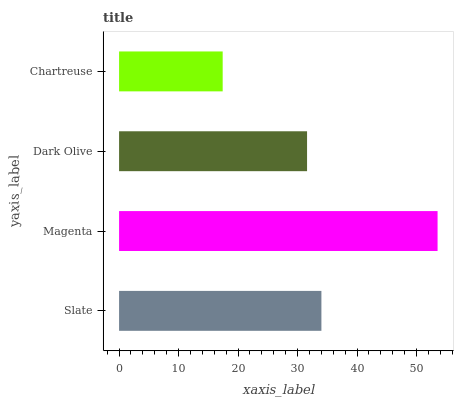Is Chartreuse the minimum?
Answer yes or no. Yes. Is Magenta the maximum?
Answer yes or no. Yes. Is Dark Olive the minimum?
Answer yes or no. No. Is Dark Olive the maximum?
Answer yes or no. No. Is Magenta greater than Dark Olive?
Answer yes or no. Yes. Is Dark Olive less than Magenta?
Answer yes or no. Yes. Is Dark Olive greater than Magenta?
Answer yes or no. No. Is Magenta less than Dark Olive?
Answer yes or no. No. Is Slate the high median?
Answer yes or no. Yes. Is Dark Olive the low median?
Answer yes or no. Yes. Is Magenta the high median?
Answer yes or no. No. Is Magenta the low median?
Answer yes or no. No. 